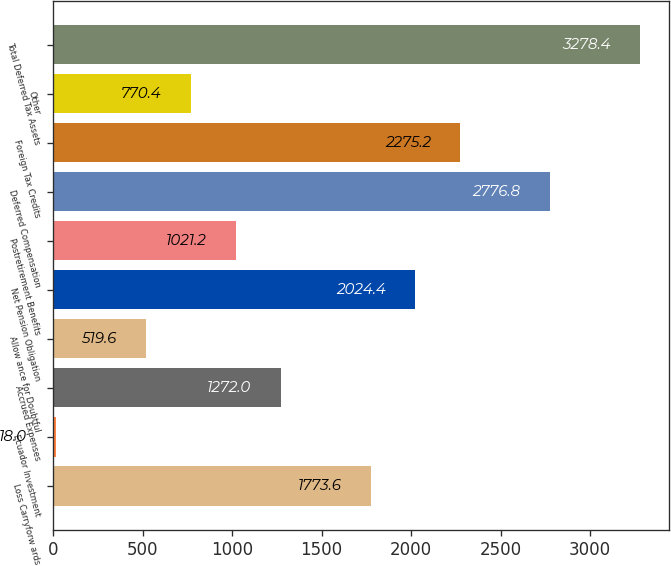Convert chart to OTSL. <chart><loc_0><loc_0><loc_500><loc_500><bar_chart><fcel>Loss Carryforw ards<fcel>Ecuador Investment<fcel>Accrued Expenses<fcel>Allow ance for Doubtful<fcel>Net Pension Obligation<fcel>Postretirement Benefits<fcel>Deferred Compensation<fcel>Foreign Tax Credits<fcel>Other<fcel>Total Deferred Tax Assets<nl><fcel>1773.6<fcel>18<fcel>1272<fcel>519.6<fcel>2024.4<fcel>1021.2<fcel>2776.8<fcel>2275.2<fcel>770.4<fcel>3278.4<nl></chart> 